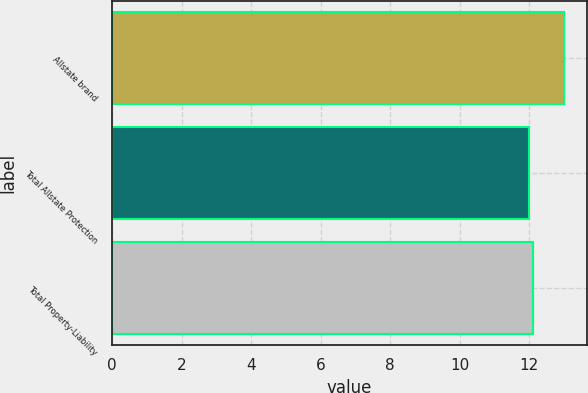Convert chart. <chart><loc_0><loc_0><loc_500><loc_500><bar_chart><fcel>Allstate brand<fcel>Total Allstate Protection<fcel>Total Property-Liability<nl><fcel>13<fcel>12<fcel>12.1<nl></chart> 